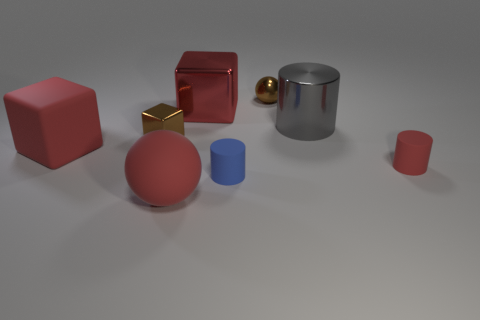Please describe the arrangement and colors of the objects in this image. In the image, we see a collection of geometric shapes with smooth surfaces. From left to right, there's a large matte pink cube, a smaller shiny red cube, and behind it lies an even smaller shiny gold cube paired closely with a tiny brown sphere. Further right stands a cylindrical silver object with a reflective surface, and there are two more objects, a matte blue cylinder and another matte pink sphere, both smaller and towards the foreground. 